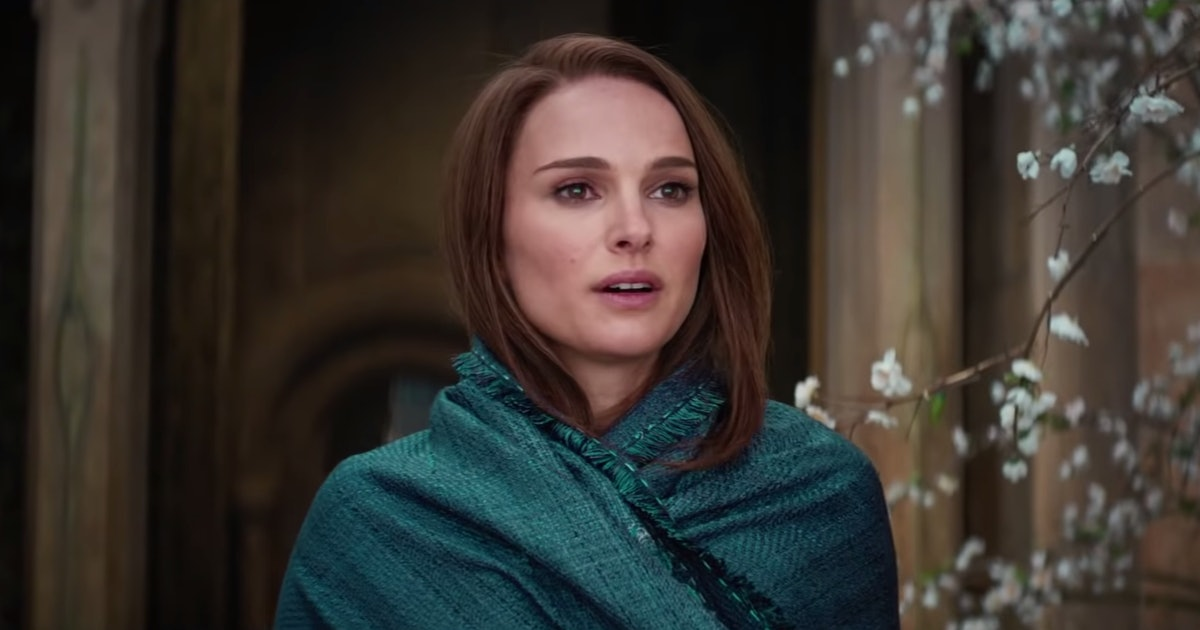Describe the following image. This image features a woman with a thoughtful expression, standing in front of an ancient stone archway. A branch with delicate white blossoms enhances the serene atmosphere. She is dressed in a striking blue-green shawl that contrasts with her dark top, adding a layer of depth to the image. Her hair falls in gentle waves, complementing her pensive mood as she gazes to the side, lost in thought. 